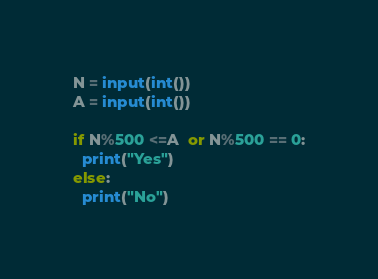Convert code to text. <code><loc_0><loc_0><loc_500><loc_500><_Python_>N = input(int())
A = input(int())

if N%500 <=A  or N%500 == 0:
  print("Yes")
else:
  print("No")
</code> 